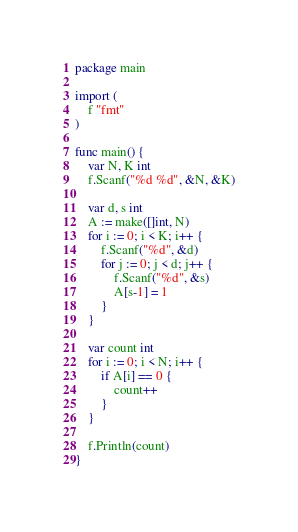Convert code to text. <code><loc_0><loc_0><loc_500><loc_500><_Go_>package main

import (
	f "fmt"
)

func main() {
	var N, K int
	f.Scanf("%d %d", &N, &K)

	var d, s int
	A := make([]int, N)
	for i := 0; i < K; i++ {
		f.Scanf("%d", &d)
		for j := 0; j < d; j++ {
			f.Scanf("%d", &s)
			A[s-1] = 1
		}
	}

	var count int
	for i := 0; i < N; i++ {
		if A[i] == 0 {
			count++
		}
	}

	f.Println(count)
}</code> 